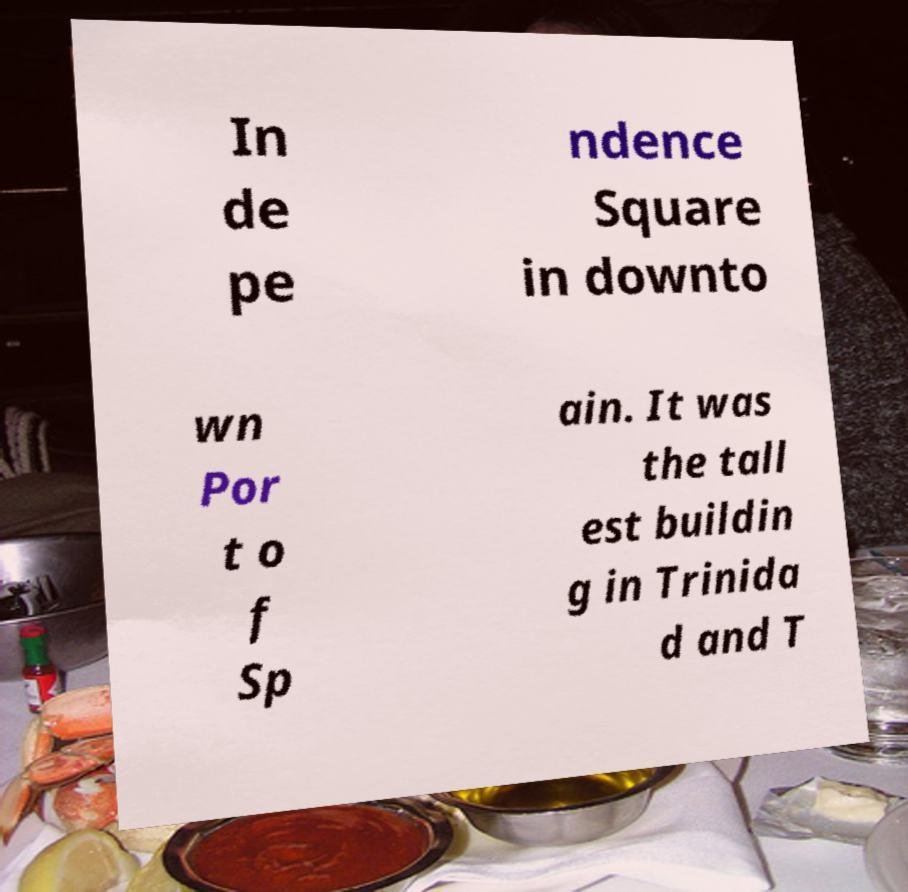I need the written content from this picture converted into text. Can you do that? In de pe ndence Square in downto wn Por t o f Sp ain. It was the tall est buildin g in Trinida d and T 